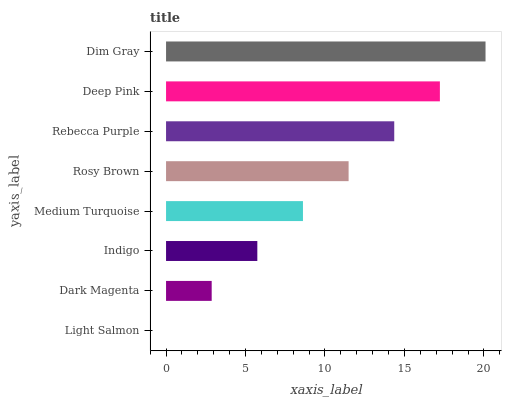Is Light Salmon the minimum?
Answer yes or no. Yes. Is Dim Gray the maximum?
Answer yes or no. Yes. Is Dark Magenta the minimum?
Answer yes or no. No. Is Dark Magenta the maximum?
Answer yes or no. No. Is Dark Magenta greater than Light Salmon?
Answer yes or no. Yes. Is Light Salmon less than Dark Magenta?
Answer yes or no. Yes. Is Light Salmon greater than Dark Magenta?
Answer yes or no. No. Is Dark Magenta less than Light Salmon?
Answer yes or no. No. Is Rosy Brown the high median?
Answer yes or no. Yes. Is Medium Turquoise the low median?
Answer yes or no. Yes. Is Indigo the high median?
Answer yes or no. No. Is Rosy Brown the low median?
Answer yes or no. No. 